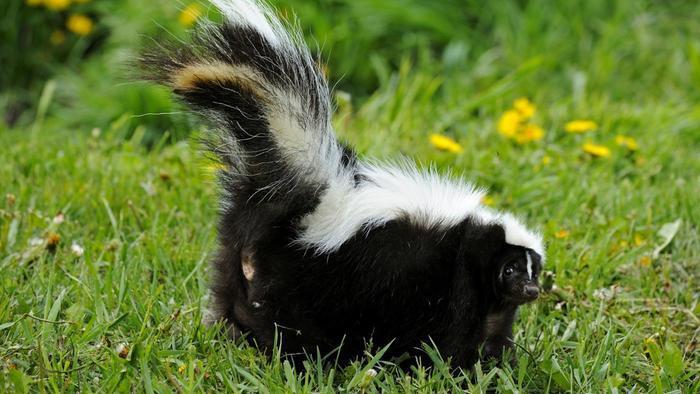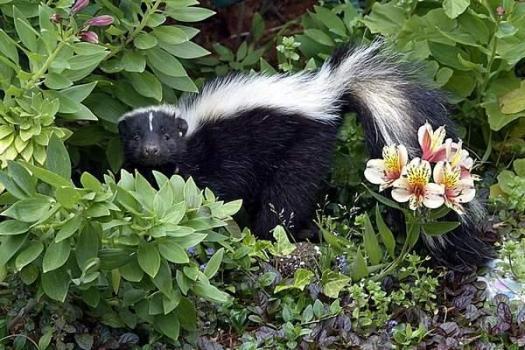The first image is the image on the left, the second image is the image on the right. Examine the images to the left and right. Is the description "At least five similar sized skunks are lined up next to each other in the grass." accurate? Answer yes or no. No. The first image is the image on the left, the second image is the image on the right. For the images shown, is this caption "An image shows a row of at least three skunks with their bodies turned forward, and at least one has its tail raised." true? Answer yes or no. No. 